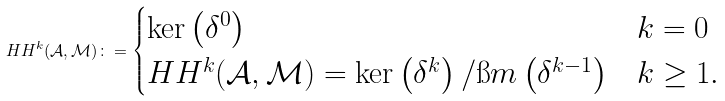<formula> <loc_0><loc_0><loc_500><loc_500>H H ^ { k } ( \mathcal { A } , \mathcal { M } ) \colon = \begin{cases} \ker \left ( \delta ^ { 0 } \right ) & k = 0 \\ H H ^ { k } ( \mathcal { A } , \mathcal { M } ) = \ker \left ( \delta ^ { k } \right ) / \i m \left ( \delta ^ { k - 1 } \right ) & k \geq 1 . \end{cases}</formula> 